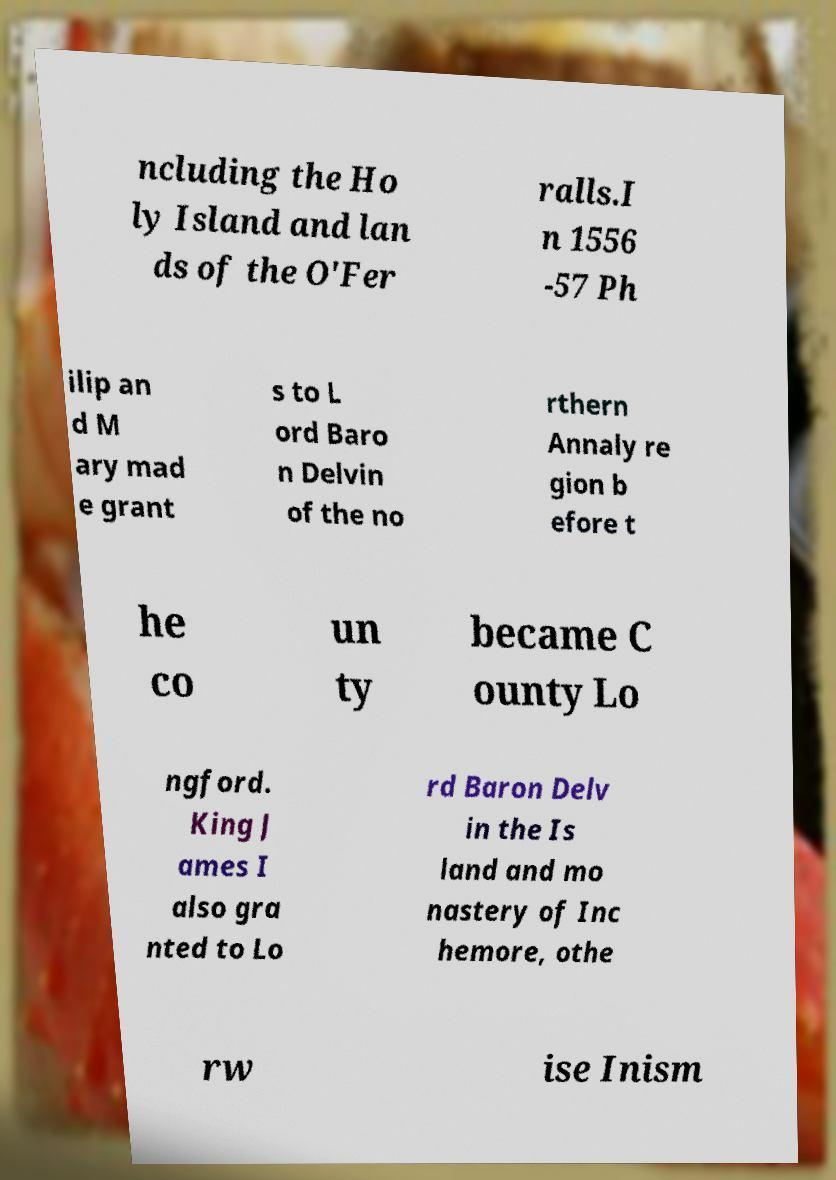Could you extract and type out the text from this image? ncluding the Ho ly Island and lan ds of the O'Fer ralls.I n 1556 -57 Ph ilip an d M ary mad e grant s to L ord Baro n Delvin of the no rthern Annaly re gion b efore t he co un ty became C ounty Lo ngford. King J ames I also gra nted to Lo rd Baron Delv in the Is land and mo nastery of Inc hemore, othe rw ise Inism 